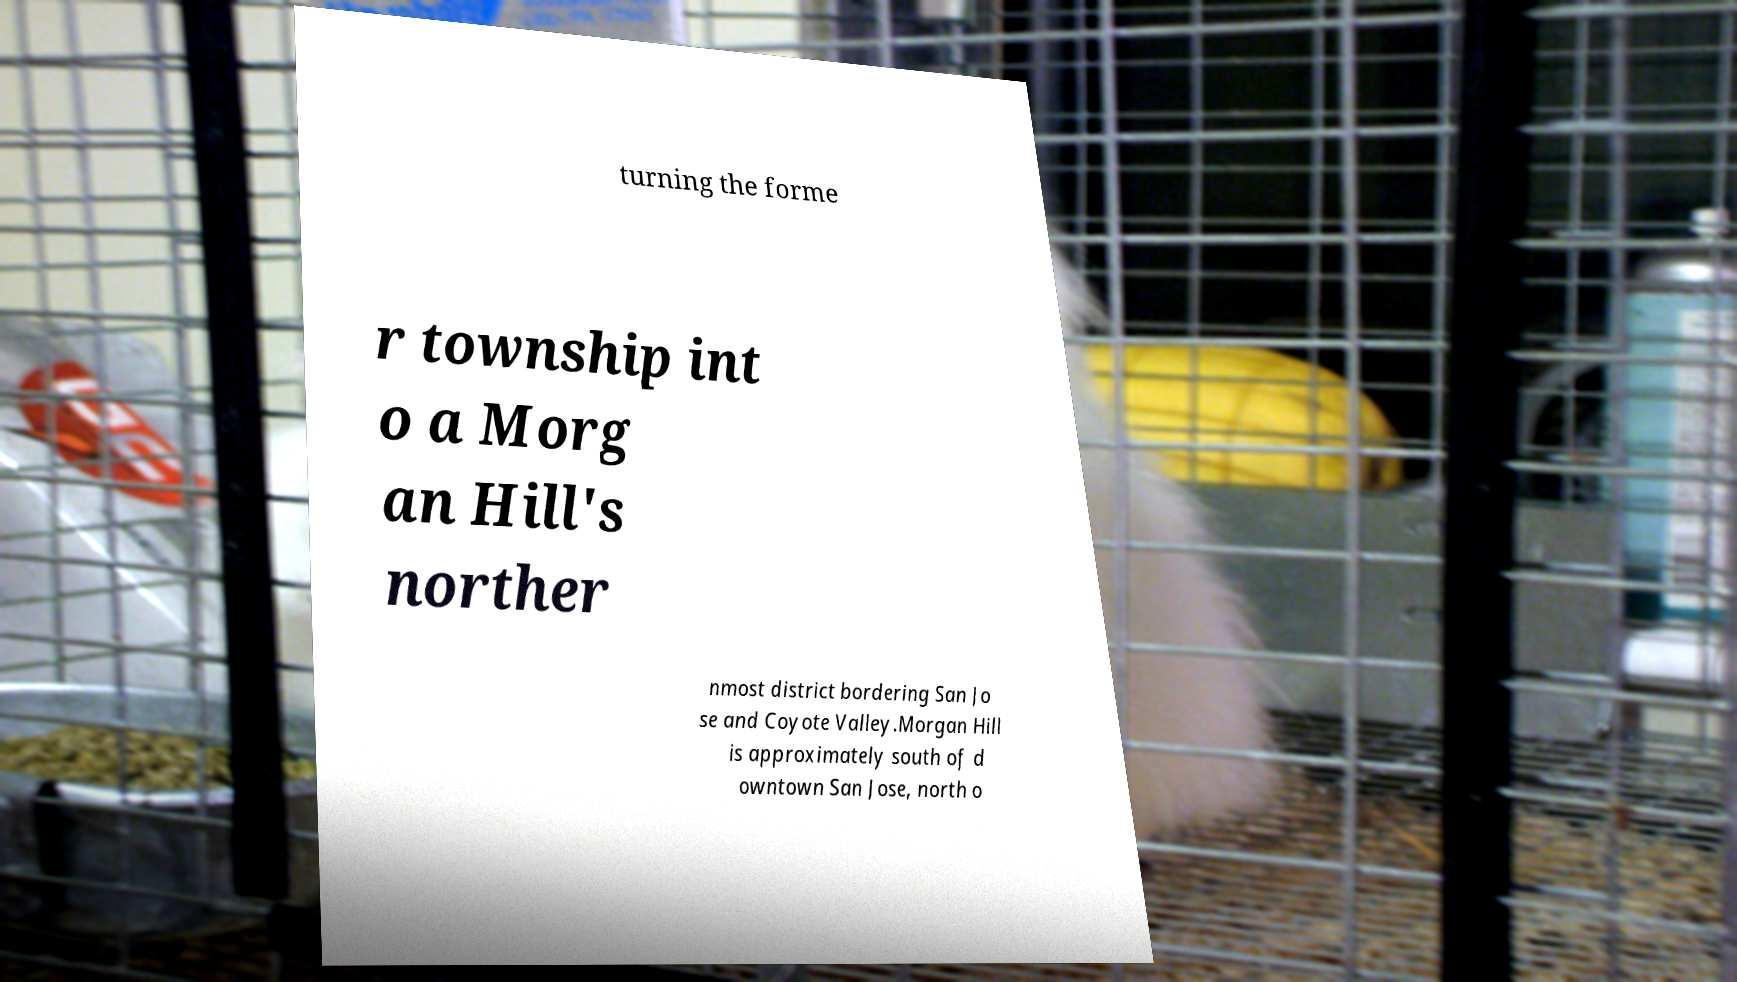Could you extract and type out the text from this image? turning the forme r township int o a Morg an Hill's norther nmost district bordering San Jo se and Coyote Valley.Morgan Hill is approximately south of d owntown San Jose, north o 